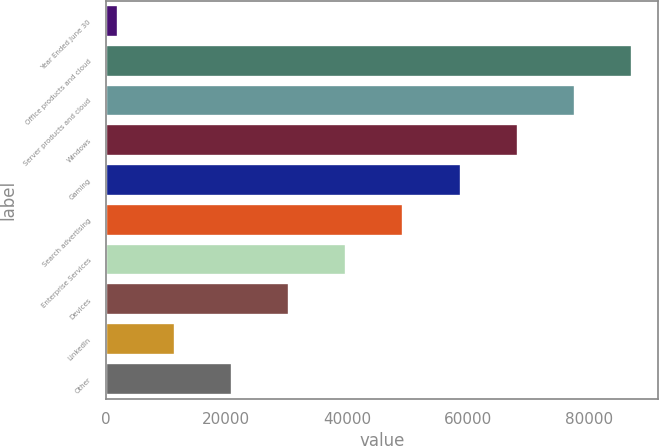Convert chart to OTSL. <chart><loc_0><loc_0><loc_500><loc_500><bar_chart><fcel>Year Ended June 30<fcel>Office products and cloud<fcel>Server products and cloud<fcel>Windows<fcel>Gaming<fcel>Search advertising<fcel>Enterprise Services<fcel>Devices<fcel>LinkedIn<fcel>Other<nl><fcel>2017<fcel>87115.6<fcel>77660.2<fcel>68204.8<fcel>58749.4<fcel>49294<fcel>39838.6<fcel>30383.2<fcel>11472.4<fcel>20927.8<nl></chart> 